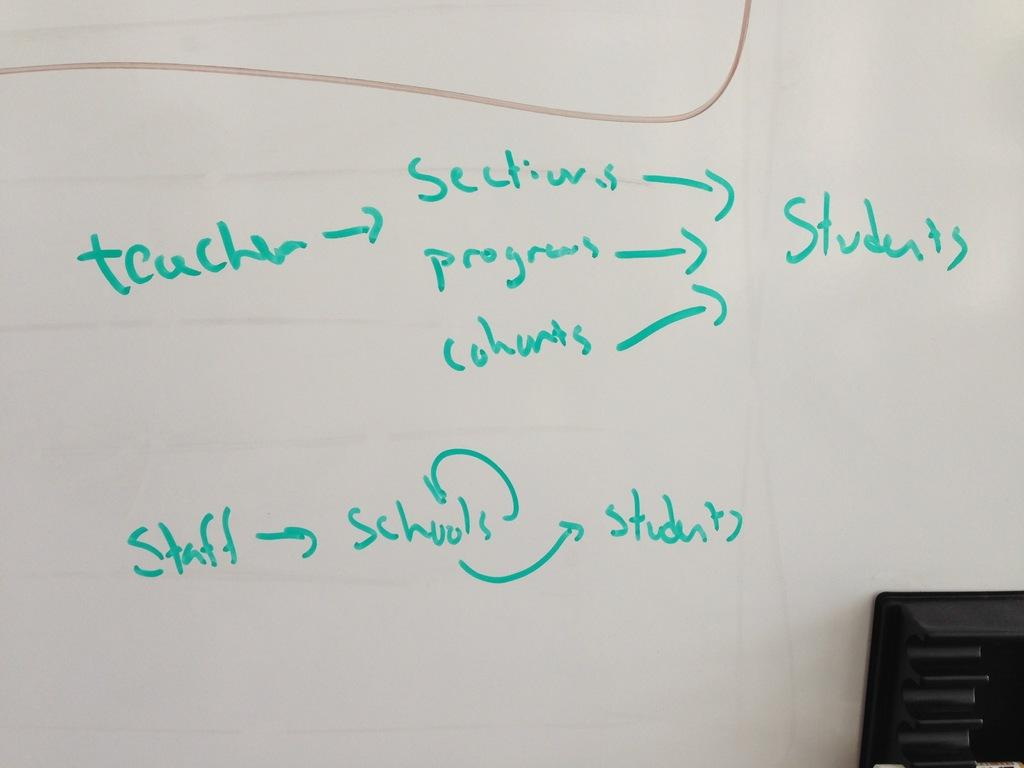What is the main object in the image? There is a whiteboard in the image. What is written on the whiteboard? There is handwritten text on the whiteboard. How many boats are stored in the drawer in the image? There are no boats or drawers present in the image; it only features a whiteboard with handwritten text. 